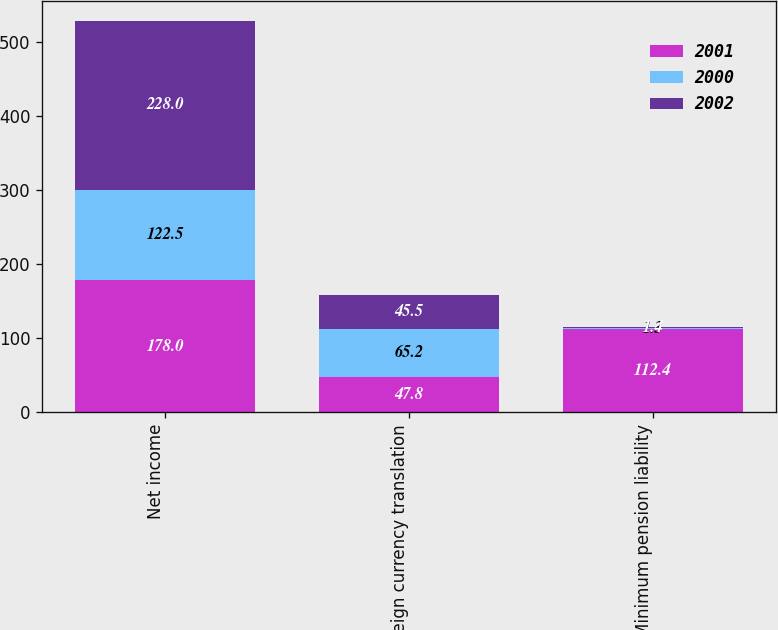Convert chart to OTSL. <chart><loc_0><loc_0><loc_500><loc_500><stacked_bar_chart><ecel><fcel>Net income<fcel>Foreign currency translation<fcel>Minimum pension liability<nl><fcel>2001<fcel>178<fcel>47.8<fcel>112.4<nl><fcel>2000<fcel>122.5<fcel>65.2<fcel>1.3<nl><fcel>2002<fcel>228<fcel>45.5<fcel>1.4<nl></chart> 